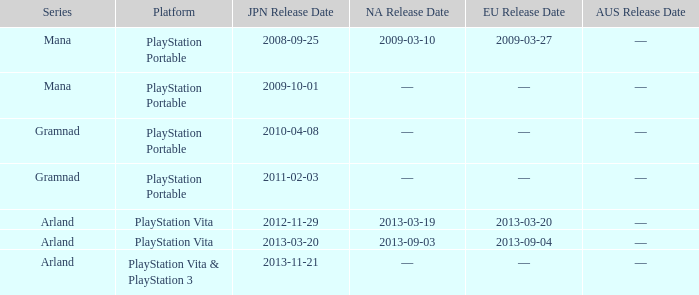What is the North American release date of the remake with a European release date on 2013-03-20? 2013-03-19. 